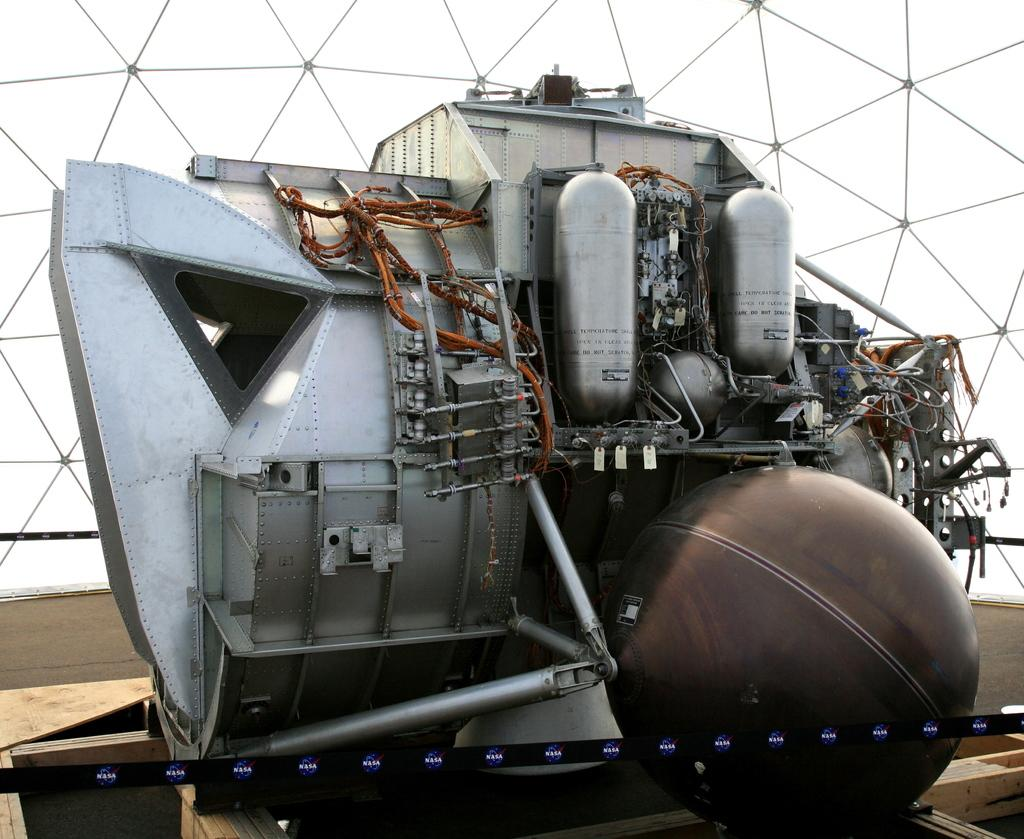What type of electronic instrument is in the middle of the image? The specific type of electronic instrument is not mentioned, but it is an electronic instrument. What is located on the right side of the image? There is a glass on the right side of the image. What can be seen in the background of the image? There is a glass window in the background of the image. What type of skirt is hanging on the glass window in the image? There is no skirt present in the image; it only features an electronic instrument, a glass, and a glass window. What color are the clouds in the image? There are no clouds visible in the image. 